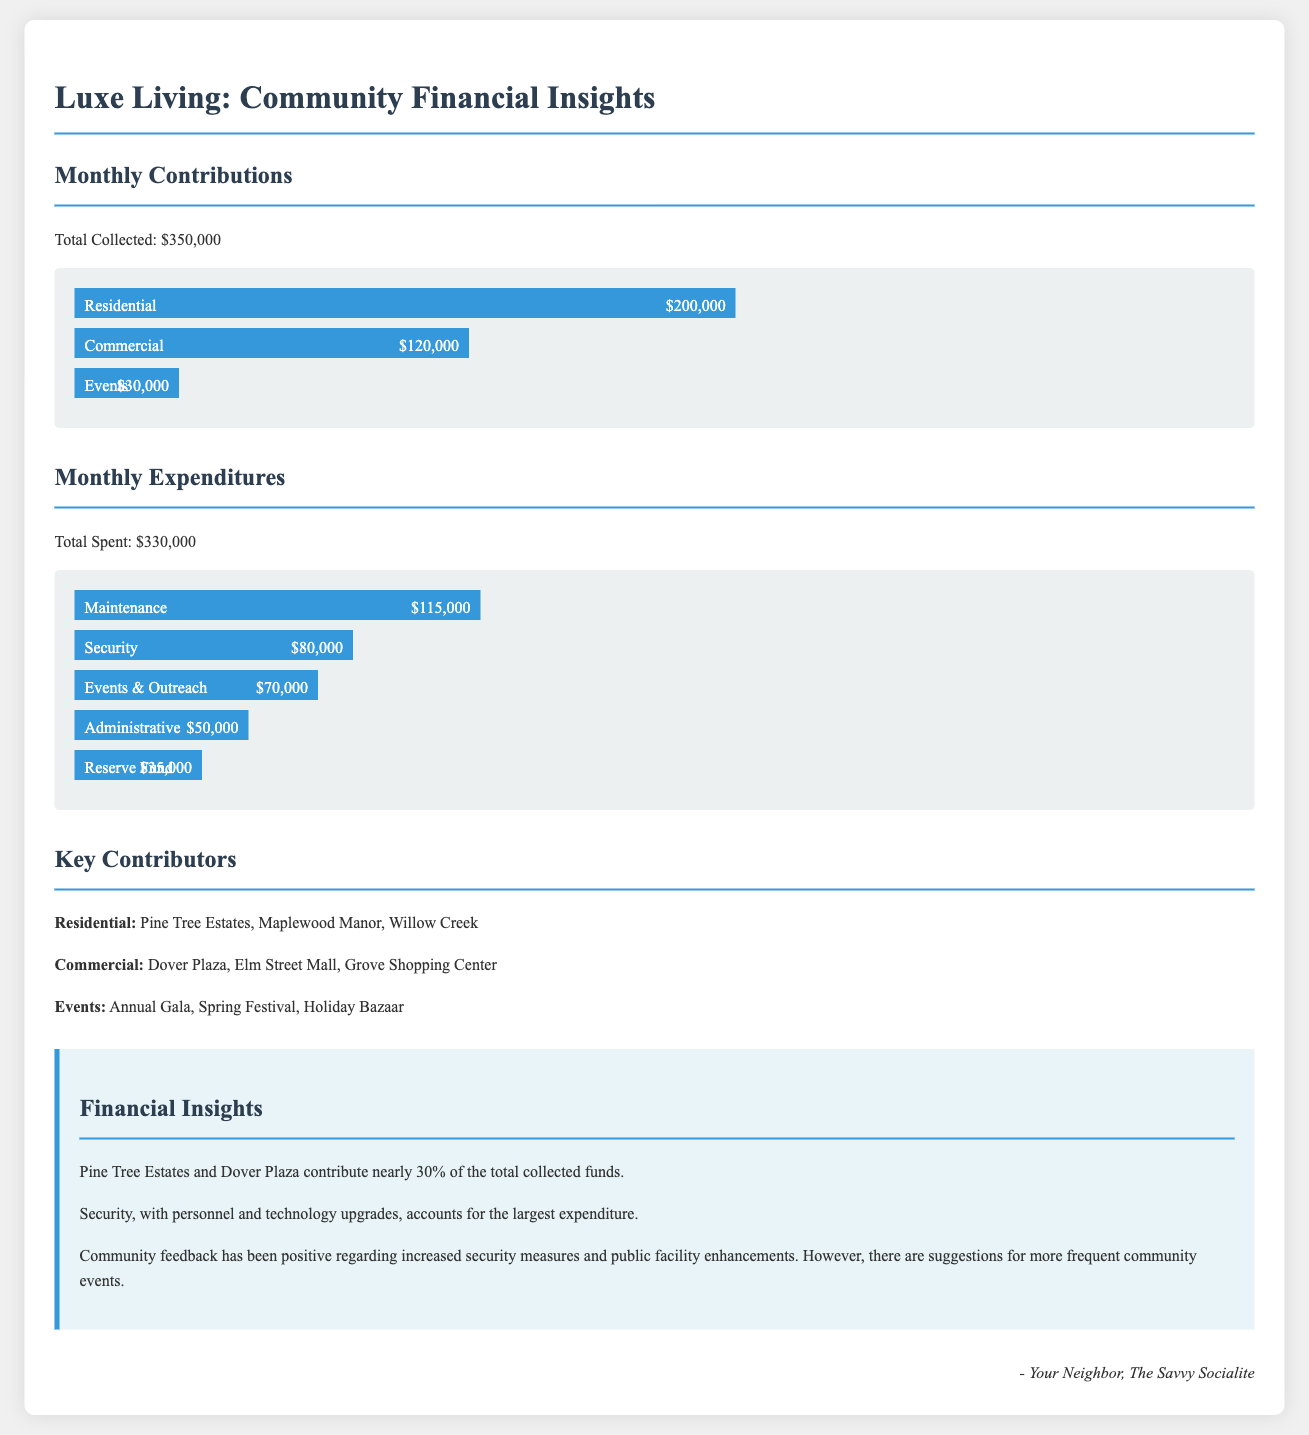What is the total amount collected in contributions? The total collected contributions amount is specified in the document.
Answer: $350,000 What are the top three sources of monthly contributions? The document lists the major contributors under the "Monthly Contributions" section.
Answer: Residential, Commercial, Events How much is spent on maintenance? The amount spent on maintenance is included in the "Monthly Expenditures" section.
Answer: $115,000 Which category has the highest expenditure? The category with the largest expenditure is mentioned in the "Monthly Expenditures" section.
Answer: Security What percentage of total contributions do Pine Tree Estates and Dover Plaza represent? The document indicates that they contribute nearly 30% of total funds.
Answer: 30% How much is allocated for the reserve fund? The reserve fund amount is specified under "Monthly Expenditures".
Answer: $35,000 What is the total amount spent in the month? The total spent amount is noted in the document.
Answer: $330,000 What type of event is mentioned under key contributors? The document lists specific events contributing to the monthly totals.
Answer: Annual Gala What are the community suggestions mentioned in the insights? The insights section contains feedback and suggestions regarding community events.
Answer: More frequent community events 